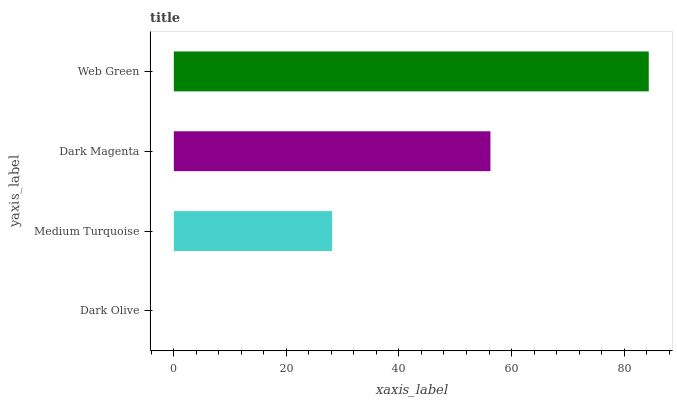Is Dark Olive the minimum?
Answer yes or no. Yes. Is Web Green the maximum?
Answer yes or no. Yes. Is Medium Turquoise the minimum?
Answer yes or no. No. Is Medium Turquoise the maximum?
Answer yes or no. No. Is Medium Turquoise greater than Dark Olive?
Answer yes or no. Yes. Is Dark Olive less than Medium Turquoise?
Answer yes or no. Yes. Is Dark Olive greater than Medium Turquoise?
Answer yes or no. No. Is Medium Turquoise less than Dark Olive?
Answer yes or no. No. Is Dark Magenta the high median?
Answer yes or no. Yes. Is Medium Turquoise the low median?
Answer yes or no. Yes. Is Medium Turquoise the high median?
Answer yes or no. No. Is Dark Olive the low median?
Answer yes or no. No. 